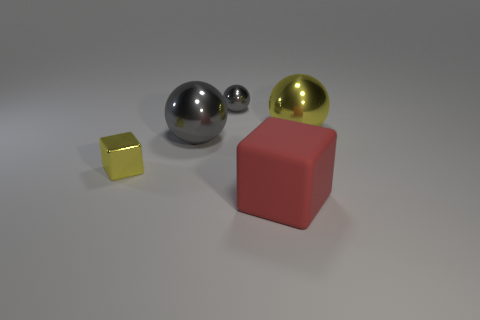Is there a metal thing that is in front of the small gray metal ball that is behind the large red matte object?
Give a very brief answer. Yes. What number of cylinders are large gray objects or tiny metal objects?
Your response must be concise. 0. How big is the yellow object that is on the left side of the small thing that is behind the cube that is behind the matte thing?
Offer a terse response. Small. There is a large gray thing; are there any tiny shiny cubes in front of it?
Your answer should be compact. Yes. What shape is the large shiny object that is the same color as the shiny cube?
Offer a terse response. Sphere. What number of things are gray metallic objects that are behind the big gray ball or big red matte spheres?
Offer a terse response. 1. What size is the yellow thing that is made of the same material as the tiny yellow block?
Offer a terse response. Large. There is a red cube; is it the same size as the gray sphere that is to the right of the big gray metallic object?
Make the answer very short. No. There is a thing that is both left of the tiny sphere and in front of the big gray thing; what color is it?
Give a very brief answer. Yellow. How many objects are either big things in front of the big yellow shiny ball or cubes that are behind the matte cube?
Your answer should be very brief. 3. 